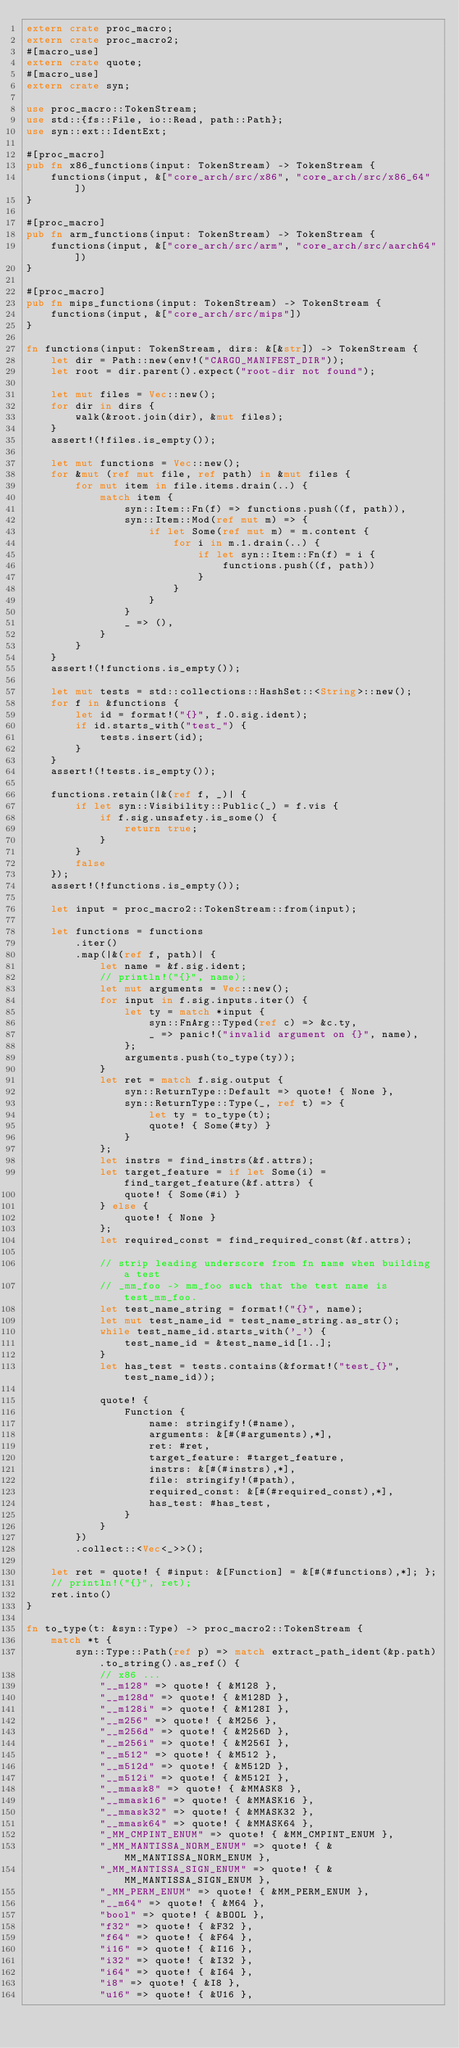Convert code to text. <code><loc_0><loc_0><loc_500><loc_500><_Rust_>extern crate proc_macro;
extern crate proc_macro2;
#[macro_use]
extern crate quote;
#[macro_use]
extern crate syn;

use proc_macro::TokenStream;
use std::{fs::File, io::Read, path::Path};
use syn::ext::IdentExt;

#[proc_macro]
pub fn x86_functions(input: TokenStream) -> TokenStream {
    functions(input, &["core_arch/src/x86", "core_arch/src/x86_64"])
}

#[proc_macro]
pub fn arm_functions(input: TokenStream) -> TokenStream {
    functions(input, &["core_arch/src/arm", "core_arch/src/aarch64"])
}

#[proc_macro]
pub fn mips_functions(input: TokenStream) -> TokenStream {
    functions(input, &["core_arch/src/mips"])
}

fn functions(input: TokenStream, dirs: &[&str]) -> TokenStream {
    let dir = Path::new(env!("CARGO_MANIFEST_DIR"));
    let root = dir.parent().expect("root-dir not found");

    let mut files = Vec::new();
    for dir in dirs {
        walk(&root.join(dir), &mut files);
    }
    assert!(!files.is_empty());

    let mut functions = Vec::new();
    for &mut (ref mut file, ref path) in &mut files {
        for mut item in file.items.drain(..) {
            match item {
                syn::Item::Fn(f) => functions.push((f, path)),
                syn::Item::Mod(ref mut m) => {
                    if let Some(ref mut m) = m.content {
                        for i in m.1.drain(..) {
                            if let syn::Item::Fn(f) = i {
                                functions.push((f, path))
                            }
                        }
                    }
                }
                _ => (),
            }
        }
    }
    assert!(!functions.is_empty());

    let mut tests = std::collections::HashSet::<String>::new();
    for f in &functions {
        let id = format!("{}", f.0.sig.ident);
        if id.starts_with("test_") {
            tests.insert(id);
        }
    }
    assert!(!tests.is_empty());

    functions.retain(|&(ref f, _)| {
        if let syn::Visibility::Public(_) = f.vis {
            if f.sig.unsafety.is_some() {
                return true;
            }
        }
        false
    });
    assert!(!functions.is_empty());

    let input = proc_macro2::TokenStream::from(input);

    let functions = functions
        .iter()
        .map(|&(ref f, path)| {
            let name = &f.sig.ident;
            // println!("{}", name);
            let mut arguments = Vec::new();
            for input in f.sig.inputs.iter() {
                let ty = match *input {
                    syn::FnArg::Typed(ref c) => &c.ty,
                    _ => panic!("invalid argument on {}", name),
                };
                arguments.push(to_type(ty));
            }
            let ret = match f.sig.output {
                syn::ReturnType::Default => quote! { None },
                syn::ReturnType::Type(_, ref t) => {
                    let ty = to_type(t);
                    quote! { Some(#ty) }
                }
            };
            let instrs = find_instrs(&f.attrs);
            let target_feature = if let Some(i) = find_target_feature(&f.attrs) {
                quote! { Some(#i) }
            } else {
                quote! { None }
            };
            let required_const = find_required_const(&f.attrs);

            // strip leading underscore from fn name when building a test
            // _mm_foo -> mm_foo such that the test name is test_mm_foo.
            let test_name_string = format!("{}", name);
            let mut test_name_id = test_name_string.as_str();
            while test_name_id.starts_with('_') {
                test_name_id = &test_name_id[1..];
            }
            let has_test = tests.contains(&format!("test_{}", test_name_id));

            quote! {
                Function {
                    name: stringify!(#name),
                    arguments: &[#(#arguments),*],
                    ret: #ret,
                    target_feature: #target_feature,
                    instrs: &[#(#instrs),*],
                    file: stringify!(#path),
                    required_const: &[#(#required_const),*],
                    has_test: #has_test,
                }
            }
        })
        .collect::<Vec<_>>();

    let ret = quote! { #input: &[Function] = &[#(#functions),*]; };
    // println!("{}", ret);
    ret.into()
}

fn to_type(t: &syn::Type) -> proc_macro2::TokenStream {
    match *t {
        syn::Type::Path(ref p) => match extract_path_ident(&p.path).to_string().as_ref() {
            // x86 ...
            "__m128" => quote! { &M128 },
            "__m128d" => quote! { &M128D },
            "__m128i" => quote! { &M128I },
            "__m256" => quote! { &M256 },
            "__m256d" => quote! { &M256D },
            "__m256i" => quote! { &M256I },
            "__m512" => quote! { &M512 },
            "__m512d" => quote! { &M512D },
            "__m512i" => quote! { &M512I },
            "__mmask8" => quote! { &MMASK8 },
            "__mmask16" => quote! { &MMASK16 },
            "__mmask32" => quote! { &MMASK32 },
            "__mmask64" => quote! { &MMASK64 },
            "_MM_CMPINT_ENUM" => quote! { &MM_CMPINT_ENUM },
            "_MM_MANTISSA_NORM_ENUM" => quote! { &MM_MANTISSA_NORM_ENUM },
            "_MM_MANTISSA_SIGN_ENUM" => quote! { &MM_MANTISSA_SIGN_ENUM },
            "_MM_PERM_ENUM" => quote! { &MM_PERM_ENUM },
            "__m64" => quote! { &M64 },
            "bool" => quote! { &BOOL },
            "f32" => quote! { &F32 },
            "f64" => quote! { &F64 },
            "i16" => quote! { &I16 },
            "i32" => quote! { &I32 },
            "i64" => quote! { &I64 },
            "i8" => quote! { &I8 },
            "u16" => quote! { &U16 },</code> 